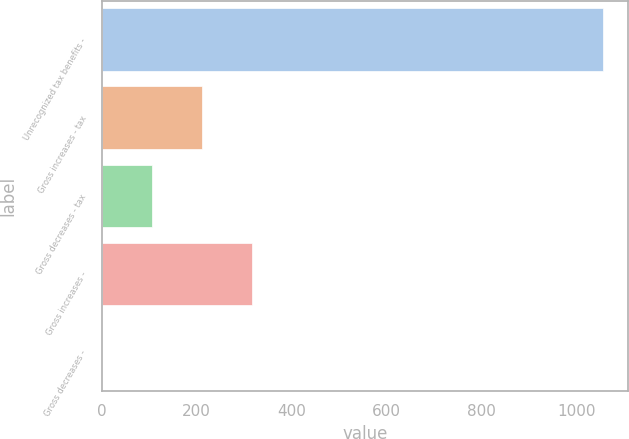Convert chart. <chart><loc_0><loc_0><loc_500><loc_500><bar_chart><fcel>Unrecognized tax benefits -<fcel>Gross increases - tax<fcel>Gross decreases - tax<fcel>Gross increases -<fcel>Gross decreases -<nl><fcel>1055<fcel>211.8<fcel>106.4<fcel>317.2<fcel>1<nl></chart> 